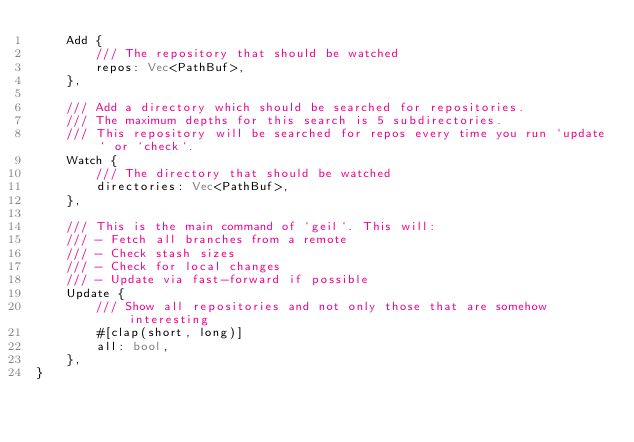Convert code to text. <code><loc_0><loc_0><loc_500><loc_500><_Rust_>    Add {
        /// The repository that should be watched
        repos: Vec<PathBuf>,
    },

    /// Add a directory which should be searched for repositories.
    /// The maximum depths for this search is 5 subdirectories.
    /// This repository will be searched for repos every time you run `update` or `check`.
    Watch {
        /// The directory that should be watched
        directories: Vec<PathBuf>,
    },

    /// This is the main command of `geil`. This will:
    /// - Fetch all branches from a remote
    /// - Check stash sizes
    /// - Check for local changes
    /// - Update via fast-forward if possible
    Update {
        /// Show all repositories and not only those that are somehow interesting
        #[clap(short, long)]
        all: bool,
    },
}
</code> 